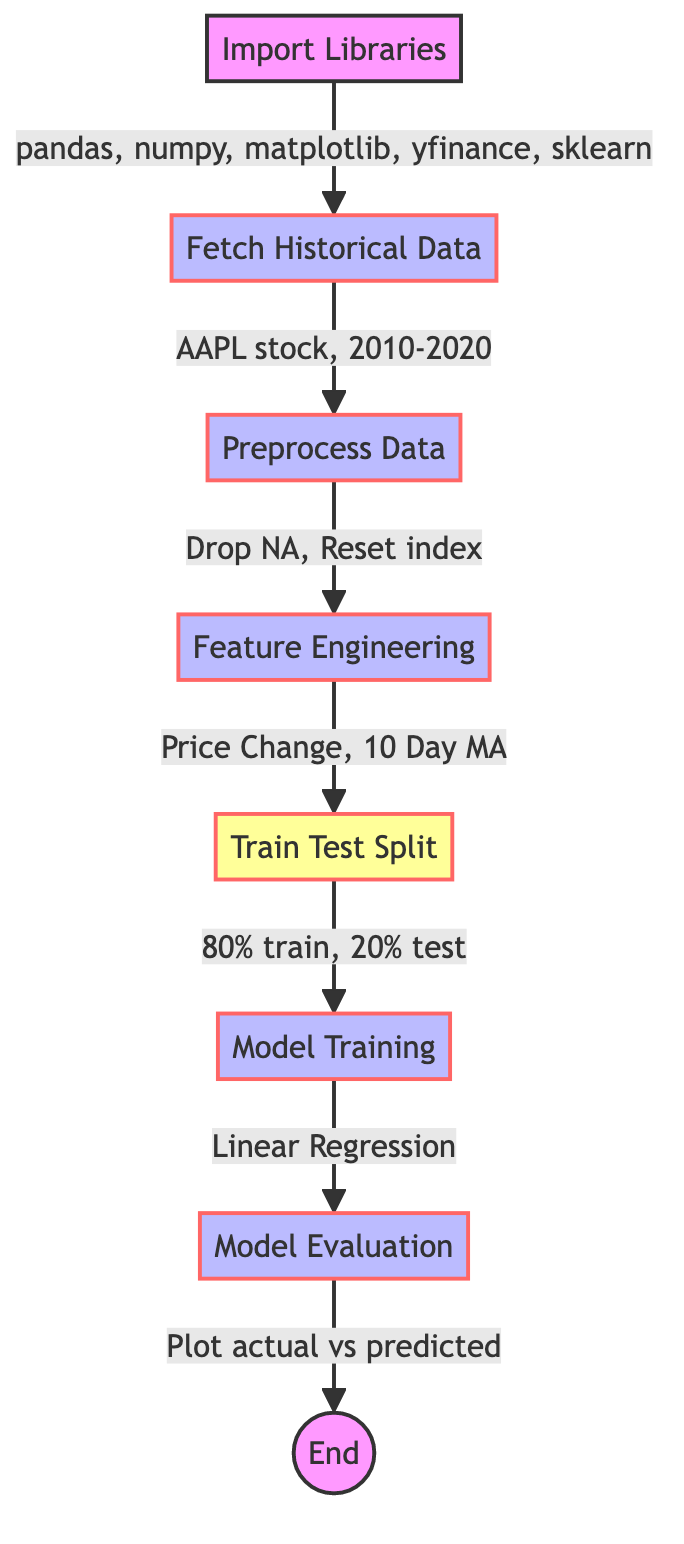What is the first step in the flowchart? The first step is "Import Libraries," and it includes the necessary libraries for data analysis.
Answer: Import Libraries How many elements are in the flowchart? The flowchart contains a total of seven elements, which represent different process steps in analyzing stock market trends.
Answer: Seven What percentage of data is used for training? The flowchart indicates that 80% of the data is allocated for training purposes in the "Train Test Split" step.
Answer: 80% What is the final output of the process? The final output of the process is to plot the actual versus predicted stock prices, as shown in the "Model Evaluation" node.
Answer: Plot actual vs predicted Which model is used for training in the flowchart? The model used for training is "Linear Regression," as specified in the "Model Training" step.
Answer: Linear Regression What operation is performed in the Feature Engineering step? In the Feature Engineering step, operations include calculating "Price Change" and "10 Day MA" (Moving Average) based on historical data.
Answer: Price Change, 10 Day MA How does data preprocessing affect further steps? Data preprocessing ensures that there are no missing values and that the data is properly organized, which is crucial for accurate model training and evaluation.
Answer: Ensures no missing values What step comes after “Preprocess Data”? After the "Preprocess Data" step, the next step is "Feature Engineering," where additional features are created from the historical data.
Answer: Feature Engineering What do we evaluate in the "Model Evaluation" step? In the "Model Evaluation" step, we evaluate the predictions made by the model against actual stock prices to assess its performance.
Answer: Predictions vs actual stock prices 